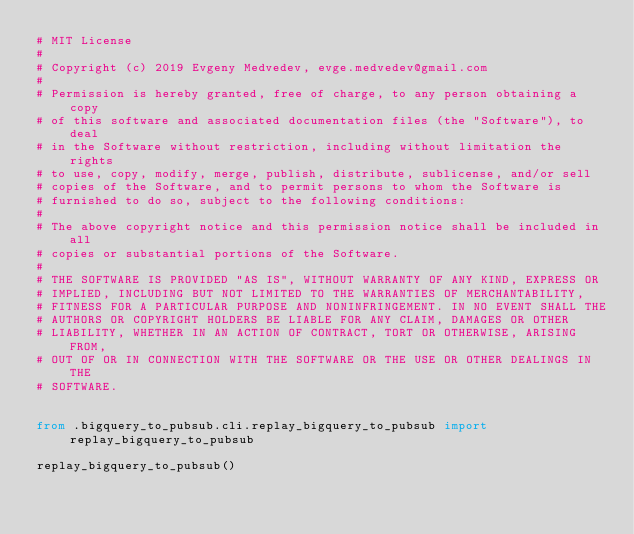<code> <loc_0><loc_0><loc_500><loc_500><_Python_># MIT License
#
# Copyright (c) 2019 Evgeny Medvedev, evge.medvedev@gmail.com
#
# Permission is hereby granted, free of charge, to any person obtaining a copy
# of this software and associated documentation files (the "Software"), to deal
# in the Software without restriction, including without limitation the rights
# to use, copy, modify, merge, publish, distribute, sublicense, and/or sell
# copies of the Software, and to permit persons to whom the Software is
# furnished to do so, subject to the following conditions:
#
# The above copyright notice and this permission notice shall be included in all
# copies or substantial portions of the Software.
#
# THE SOFTWARE IS PROVIDED "AS IS", WITHOUT WARRANTY OF ANY KIND, EXPRESS OR
# IMPLIED, INCLUDING BUT NOT LIMITED TO THE WARRANTIES OF MERCHANTABILITY,
# FITNESS FOR A PARTICULAR PURPOSE AND NONINFRINGEMENT. IN NO EVENT SHALL THE
# AUTHORS OR COPYRIGHT HOLDERS BE LIABLE FOR ANY CLAIM, DAMAGES OR OTHER
# LIABILITY, WHETHER IN AN ACTION OF CONTRACT, TORT OR OTHERWISE, ARISING FROM,
# OUT OF OR IN CONNECTION WITH THE SOFTWARE OR THE USE OR OTHER DEALINGS IN THE
# SOFTWARE.


from .bigquery_to_pubsub.cli.replay_bigquery_to_pubsub import replay_bigquery_to_pubsub

replay_bigquery_to_pubsub()
</code> 